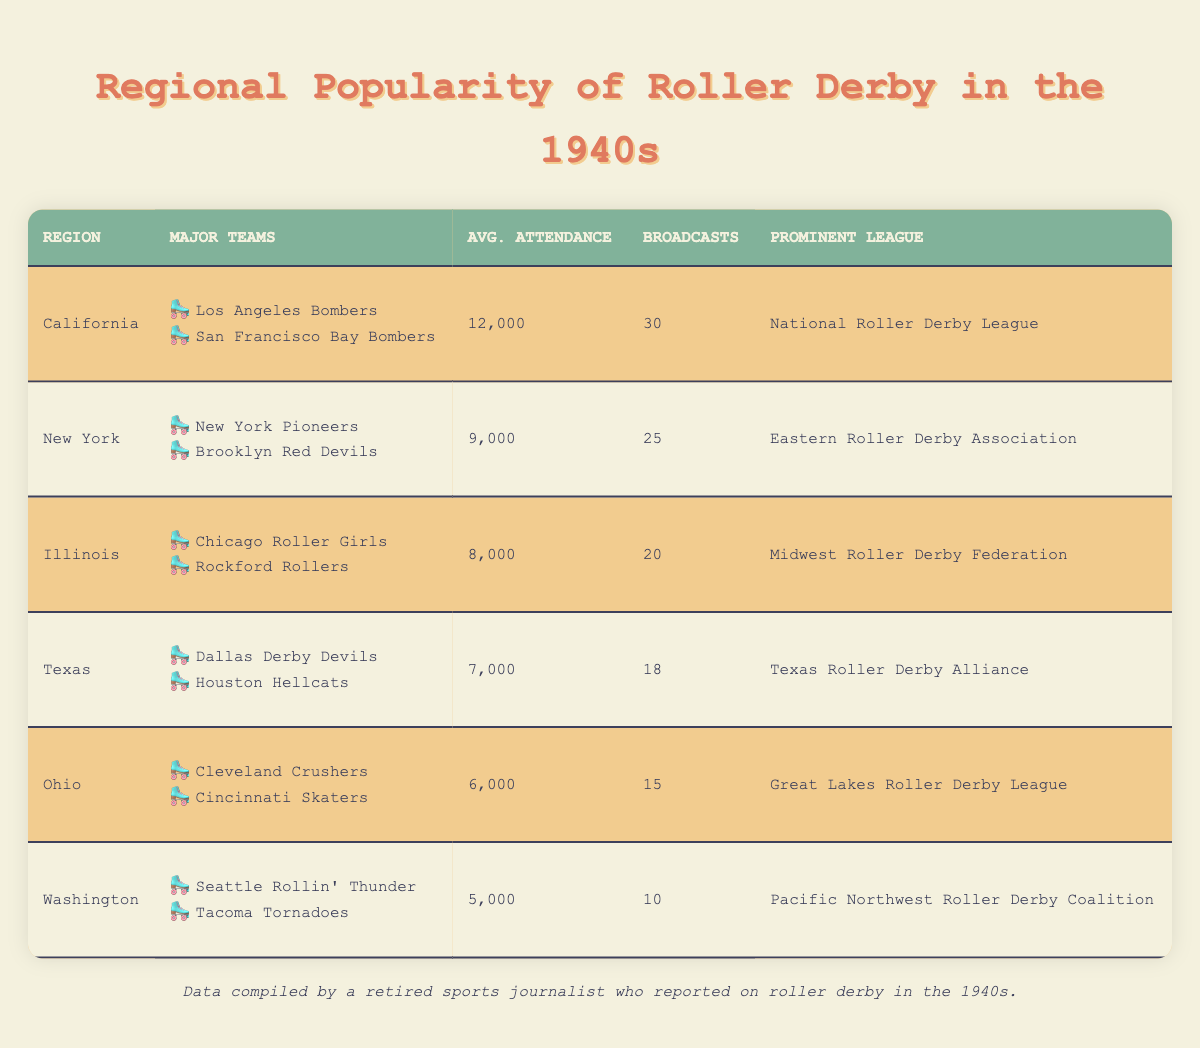What is the average attendance in California? The table indicates that California has an average attendance of 12,000.
Answer: 12,000 Which region has the highest number of broadcasts? California has the highest number of broadcasts at 30.
Answer: California How many total broadcasts are there across all regions? Adding the number of broadcasts from each region: 30 (California) + 25 (New York) + 20 (Illinois) + 18 (Texas) + 15 (Ohio) + 10 (Washington) = 118.
Answer: 118 Are there more major teams in New York than in Texas? New York has 2 major teams (New York Pioneers, Brooklyn Red Devils) and Texas also has 2 major teams (Dallas Derby Devils, Houston Hellcats), so the number of teams is equal.
Answer: No In which region is the prominent league the Eastern Roller Derby Association? The prominent league for New York is the Eastern Roller Derby Association.
Answer: New York What is the difference in average attendance between the highest and lowest regions? California has the highest average attendance at 12,000 and Washington has the lowest at 5,000. The difference is 12,000 - 5,000 = 7,000.
Answer: 7,000 Is Ohio more popular for roller derby than Illinois based on average attendance? Ohio has an attendance average of 6,000, while Illinois has 8,000. Therefore, Illinois is more popular based on attendance.
Answer: No Which region has the lowest average attendance? The table shows that Washington has the lowest average attendance at 5,000.
Answer: Washington What are the major teams in Illinois? The major teams in Illinois are the Chicago Roller Girls and the Rockford Rollers.
Answer: Chicago Roller Girls, Rockford Rollers 